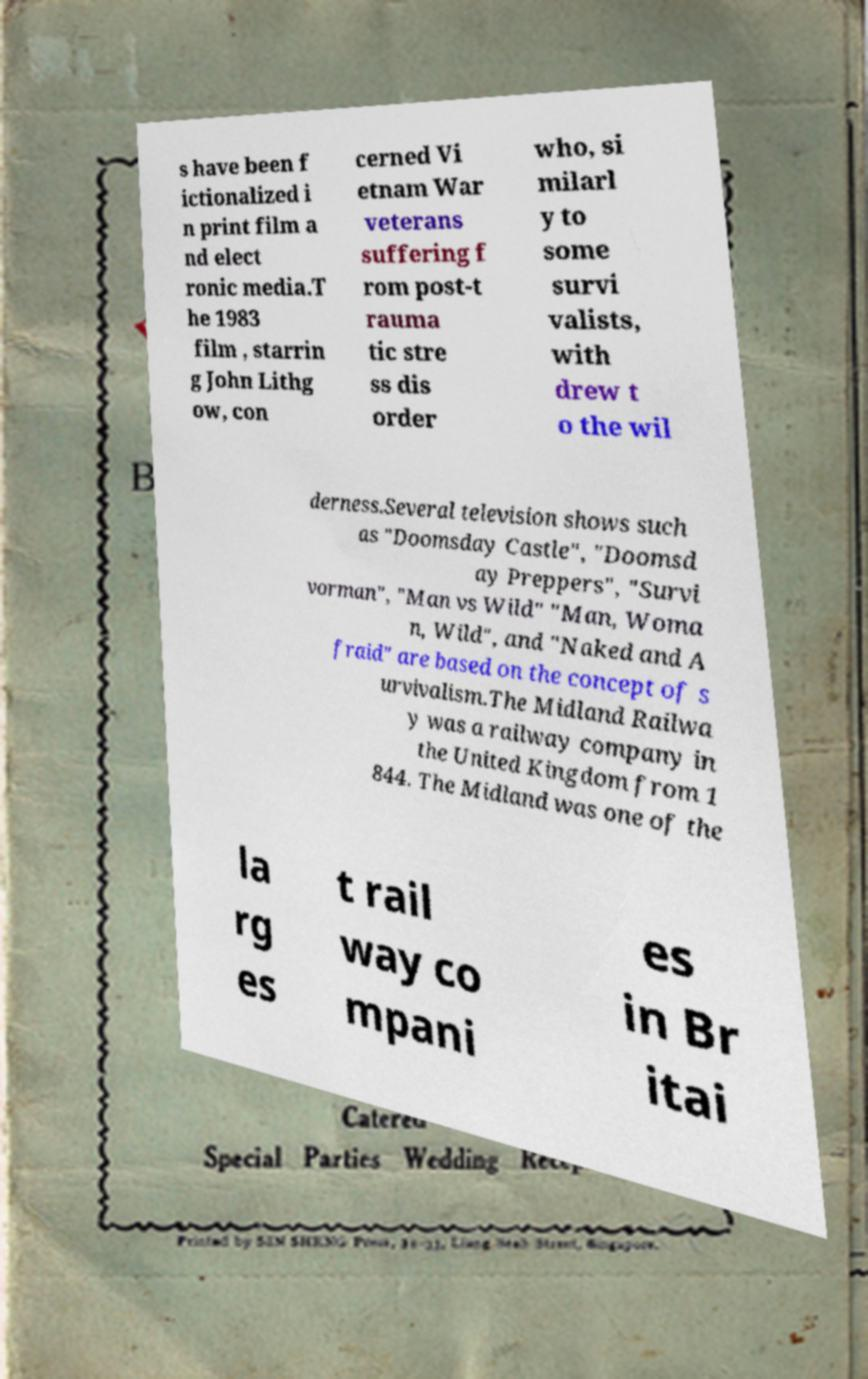I need the written content from this picture converted into text. Can you do that? s have been f ictionalized i n print film a nd elect ronic media.T he 1983 film , starrin g John Lithg ow, con cerned Vi etnam War veterans suffering f rom post-t rauma tic stre ss dis order who, si milarl y to some survi valists, with drew t o the wil derness.Several television shows such as "Doomsday Castle", "Doomsd ay Preppers", "Survi vorman", "Man vs Wild" "Man, Woma n, Wild", and "Naked and A fraid" are based on the concept of s urvivalism.The Midland Railwa y was a railway company in the United Kingdom from 1 844. The Midland was one of the la rg es t rail way co mpani es in Br itai 